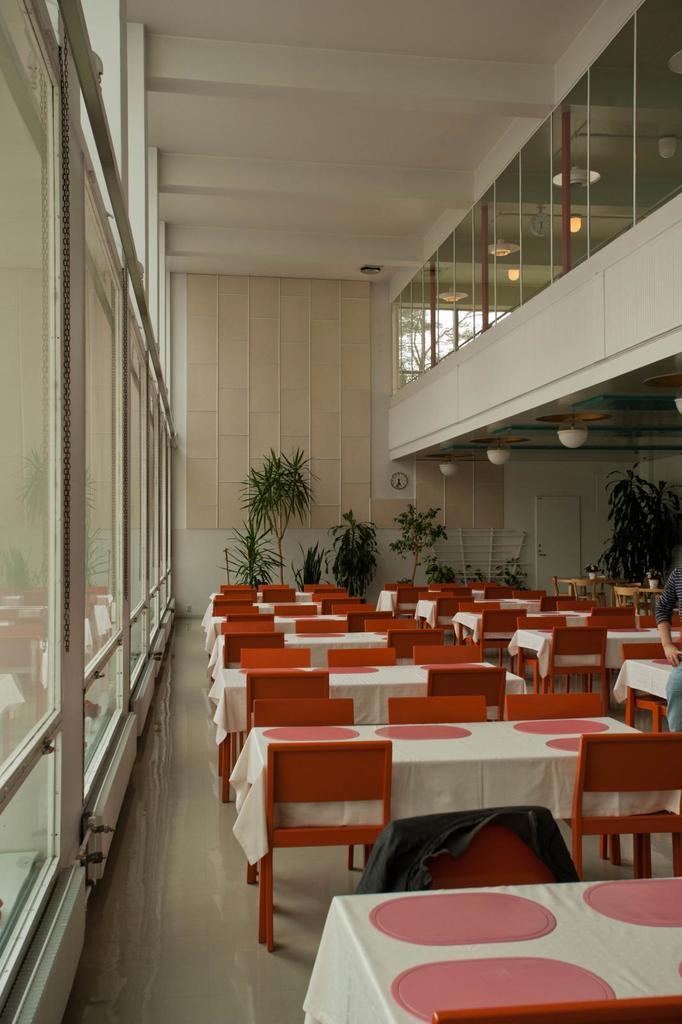Can you describe this image briefly? This picture is clicked inside the room and we can see the tables, chairs. On the right corner we can see a person and we can see the house plants, wall, roof, lights and some other objects. 